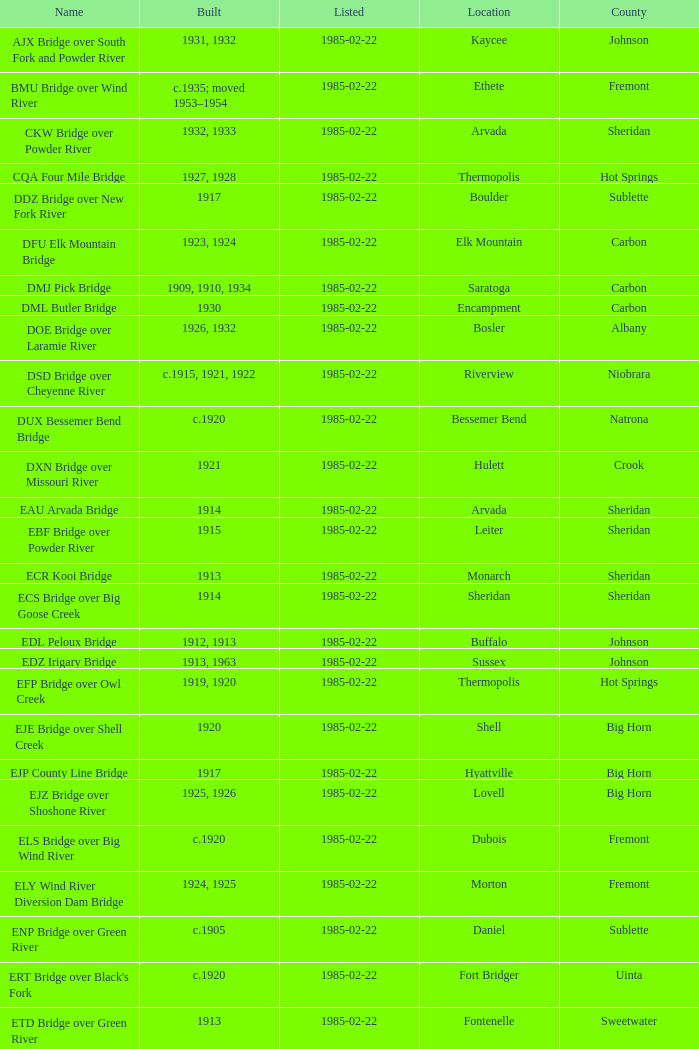In what year was the bridge in Lovell built? 1925, 1926. 